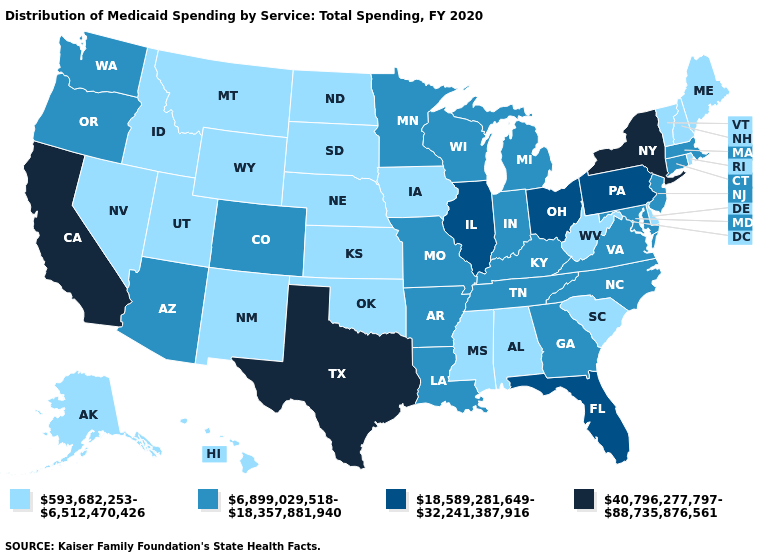What is the value of Illinois?
Write a very short answer. 18,589,281,649-32,241,387,916. Among the states that border Colorado , which have the highest value?
Be succinct. Arizona. Does the first symbol in the legend represent the smallest category?
Give a very brief answer. Yes. Does the first symbol in the legend represent the smallest category?
Quick response, please. Yes. Does New Jersey have the highest value in the USA?
Concise answer only. No. Does Massachusetts have the highest value in the Northeast?
Keep it brief. No. How many symbols are there in the legend?
Quick response, please. 4. Which states have the highest value in the USA?
Give a very brief answer. California, New York, Texas. Does California have the highest value in the West?
Answer briefly. Yes. Name the states that have a value in the range 593,682,253-6,512,470,426?
Answer briefly. Alabama, Alaska, Delaware, Hawaii, Idaho, Iowa, Kansas, Maine, Mississippi, Montana, Nebraska, Nevada, New Hampshire, New Mexico, North Dakota, Oklahoma, Rhode Island, South Carolina, South Dakota, Utah, Vermont, West Virginia, Wyoming. Name the states that have a value in the range 593,682,253-6,512,470,426?
Answer briefly. Alabama, Alaska, Delaware, Hawaii, Idaho, Iowa, Kansas, Maine, Mississippi, Montana, Nebraska, Nevada, New Hampshire, New Mexico, North Dakota, Oklahoma, Rhode Island, South Carolina, South Dakota, Utah, Vermont, West Virginia, Wyoming. Does Indiana have the highest value in the USA?
Give a very brief answer. No. Does Virginia have the lowest value in the USA?
Short answer required. No. What is the value of South Carolina?
Give a very brief answer. 593,682,253-6,512,470,426. What is the highest value in states that border Kansas?
Be succinct. 6,899,029,518-18,357,881,940. 